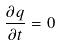<formula> <loc_0><loc_0><loc_500><loc_500>\frac { \partial q } { \partial t } = 0</formula> 